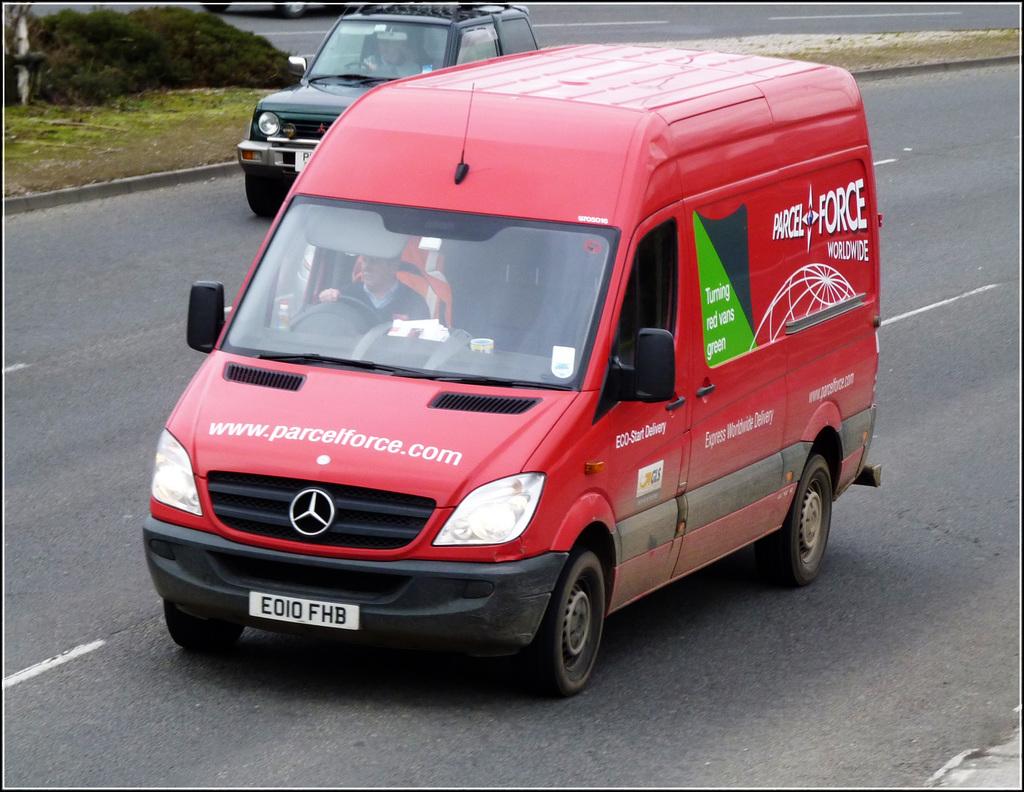What website is on the van?
Give a very brief answer. Www.parcelforce.com. 